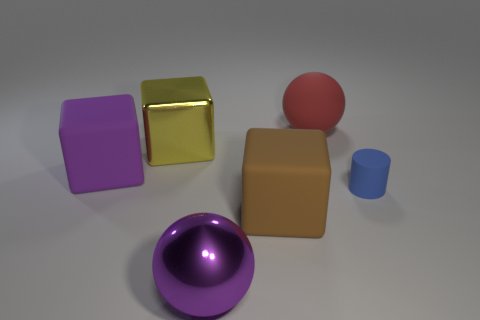Subtract all rubber cubes. How many cubes are left? 1 Subtract all purple blocks. How many blocks are left? 2 Subtract all spheres. How many objects are left? 4 Add 4 small things. How many small things are left? 5 Add 5 big shiny blocks. How many big shiny blocks exist? 6 Add 3 tiny yellow matte spheres. How many objects exist? 9 Subtract 1 red spheres. How many objects are left? 5 Subtract 1 cylinders. How many cylinders are left? 0 Subtract all green spheres. Subtract all yellow cylinders. How many spheres are left? 2 Subtract all brown cubes. How many brown spheres are left? 0 